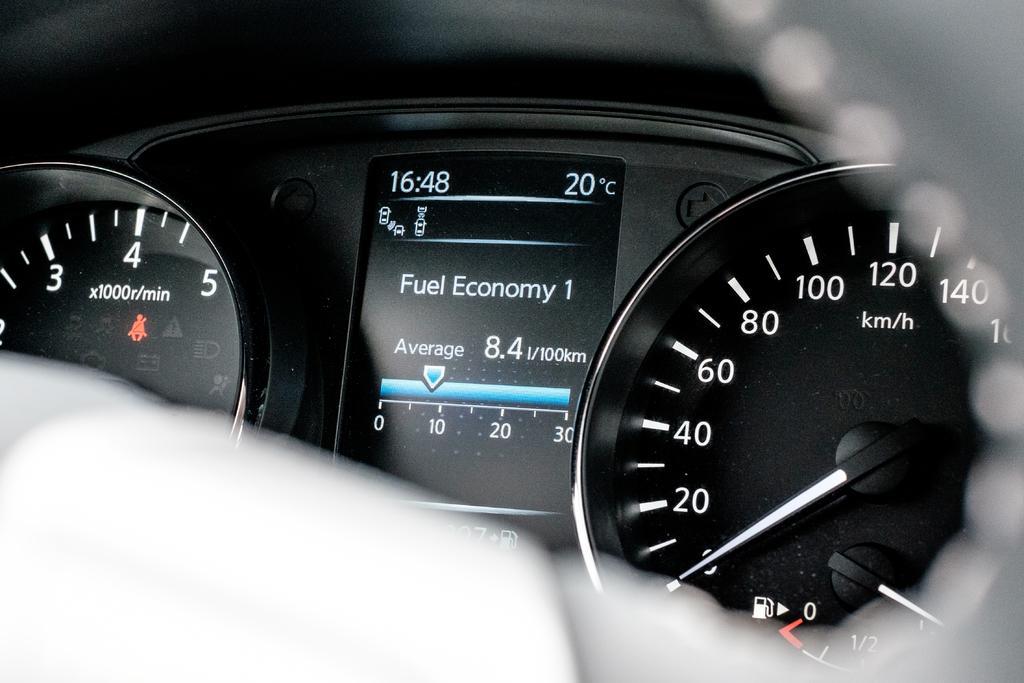Could you give a brief overview of what you see in this image? In this image in the center there is a vehicle's speed meters are visible, and at the top and bottom there is blurry. 